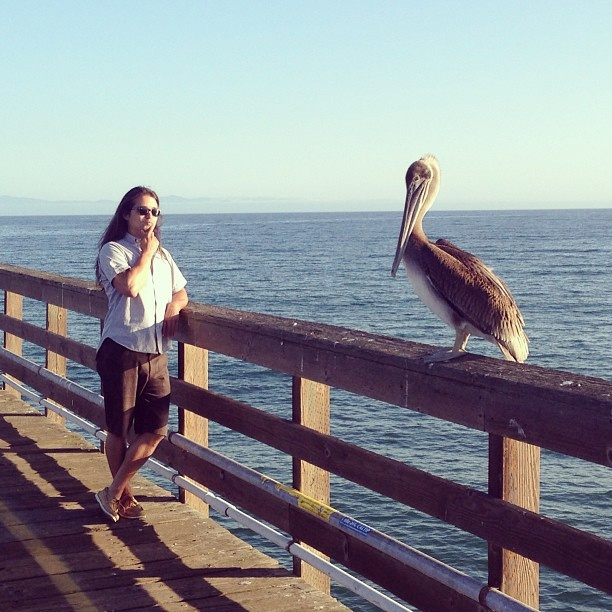Describe the objects in this image and their specific colors. I can see people in lightblue, black, beige, and purple tones and bird in lightblue, black, gray, darkgray, and purple tones in this image. 